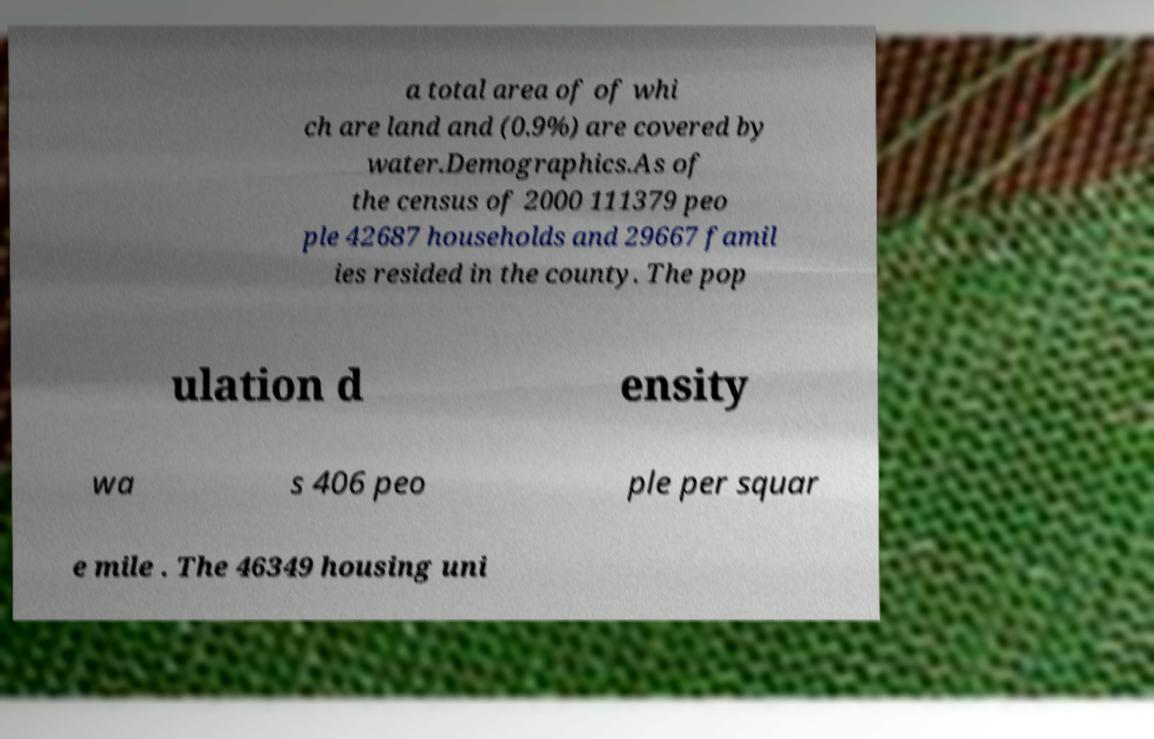There's text embedded in this image that I need extracted. Can you transcribe it verbatim? a total area of of whi ch are land and (0.9%) are covered by water.Demographics.As of the census of 2000 111379 peo ple 42687 households and 29667 famil ies resided in the county. The pop ulation d ensity wa s 406 peo ple per squar e mile . The 46349 housing uni 